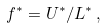<formula> <loc_0><loc_0><loc_500><loc_500>f ^ { * } = U ^ { * } / L ^ { * } \, ,</formula> 